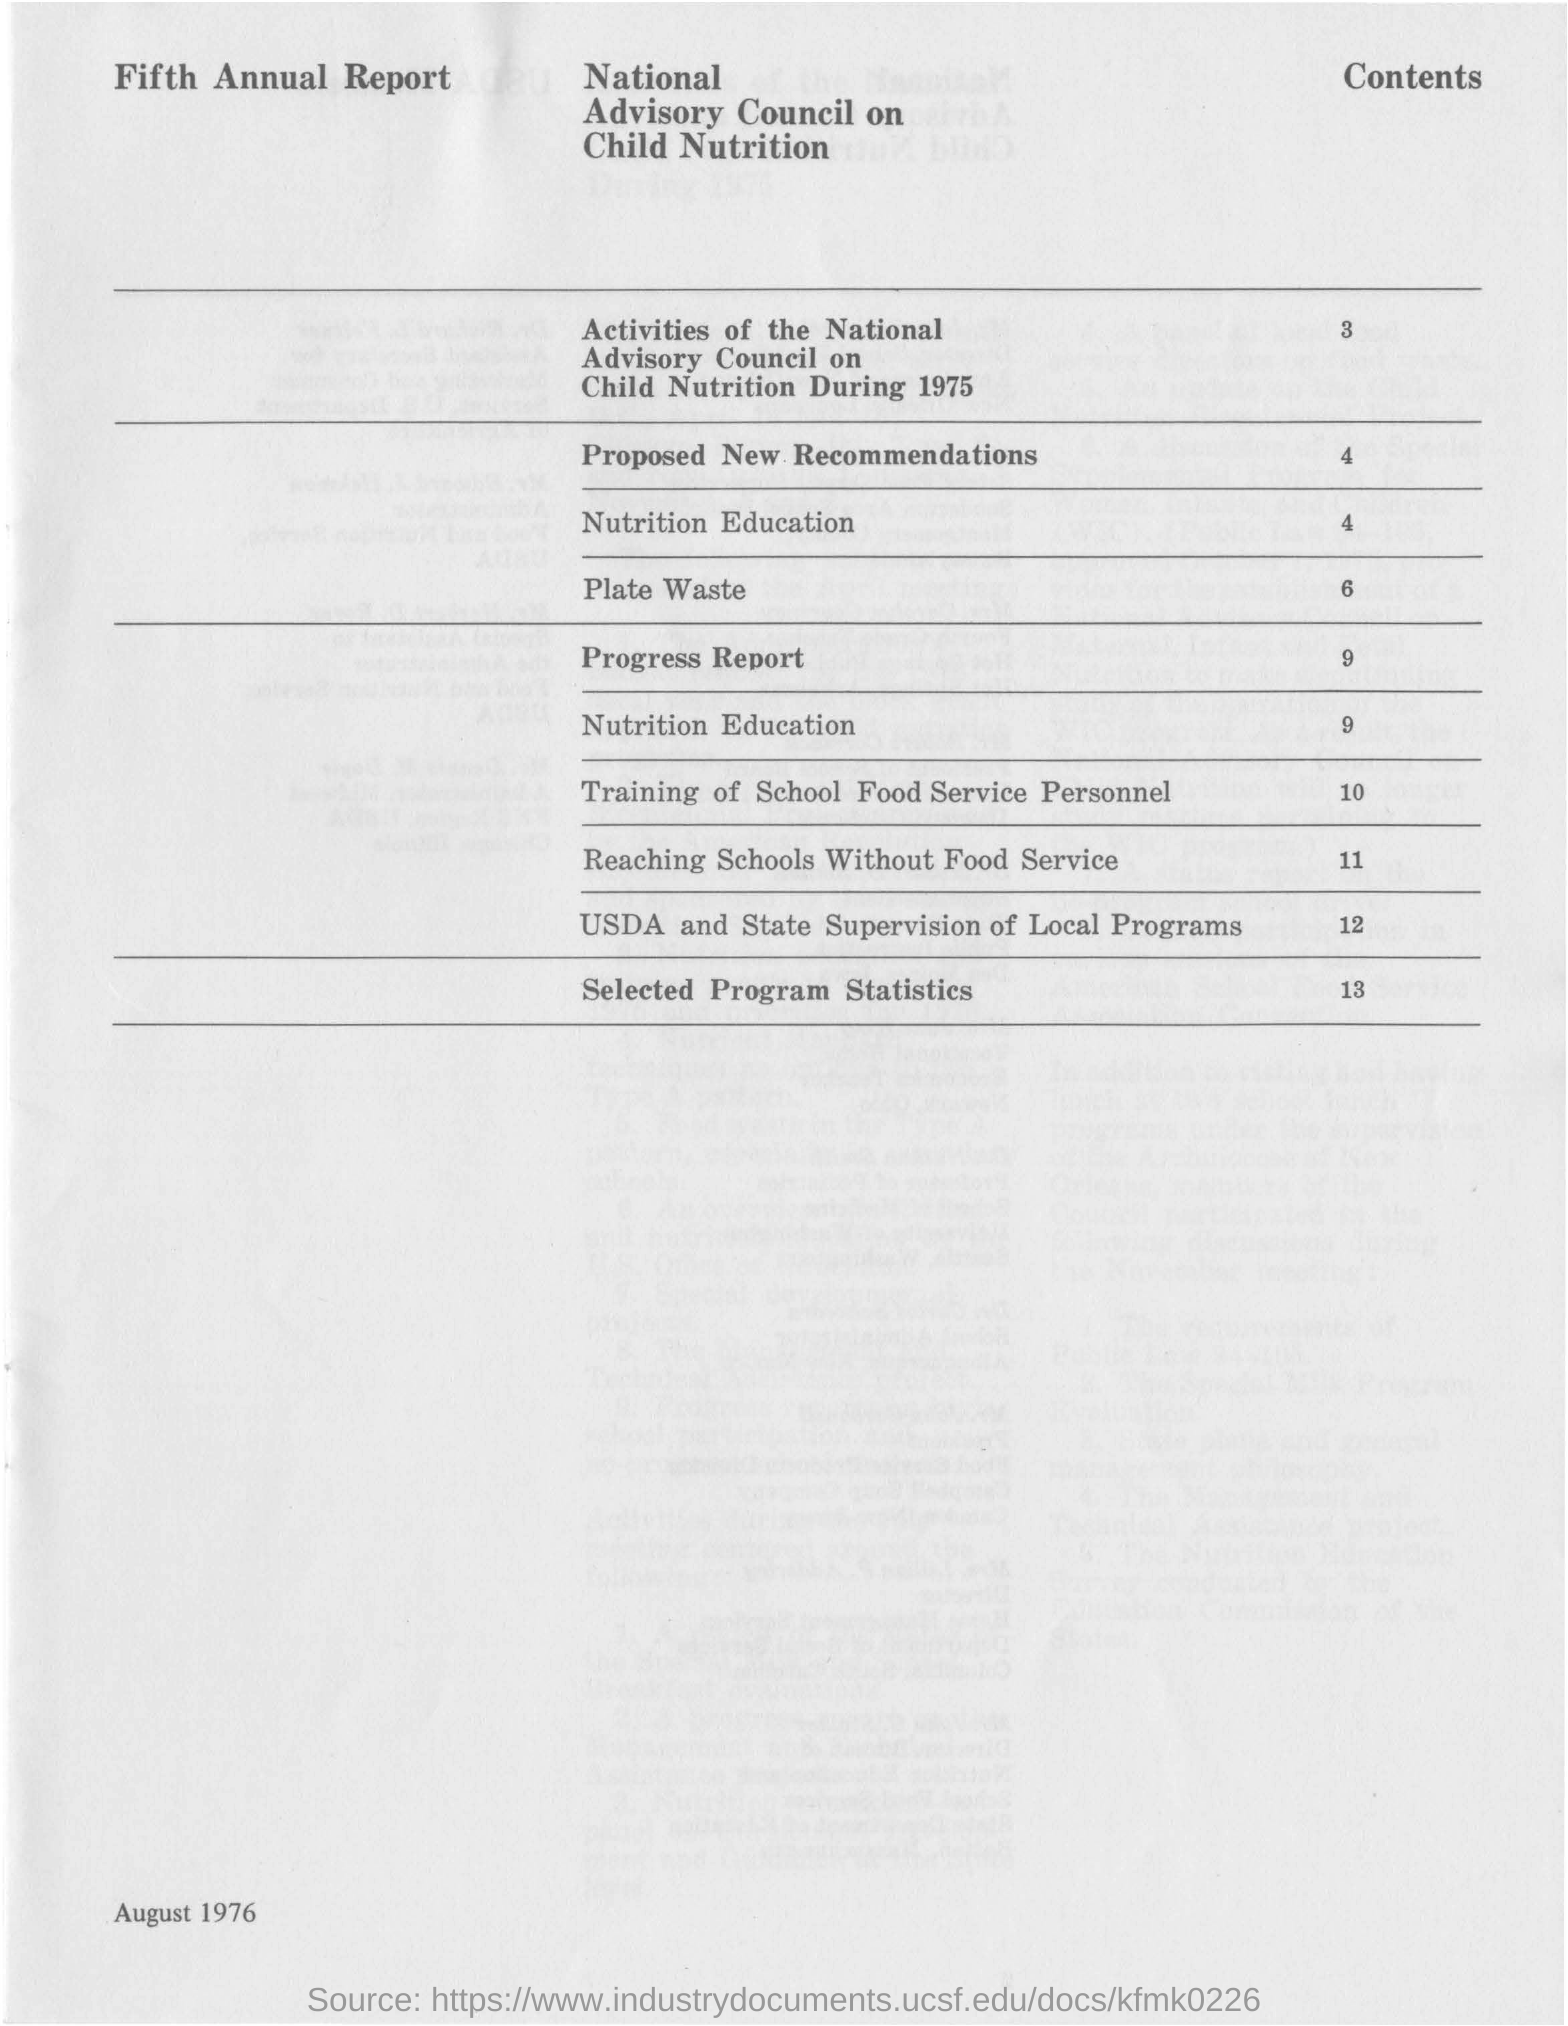Outline some significant characteristics in this image. The date mentioned in this document is August 1976. The page number of the proposed new recommendations is 4. 